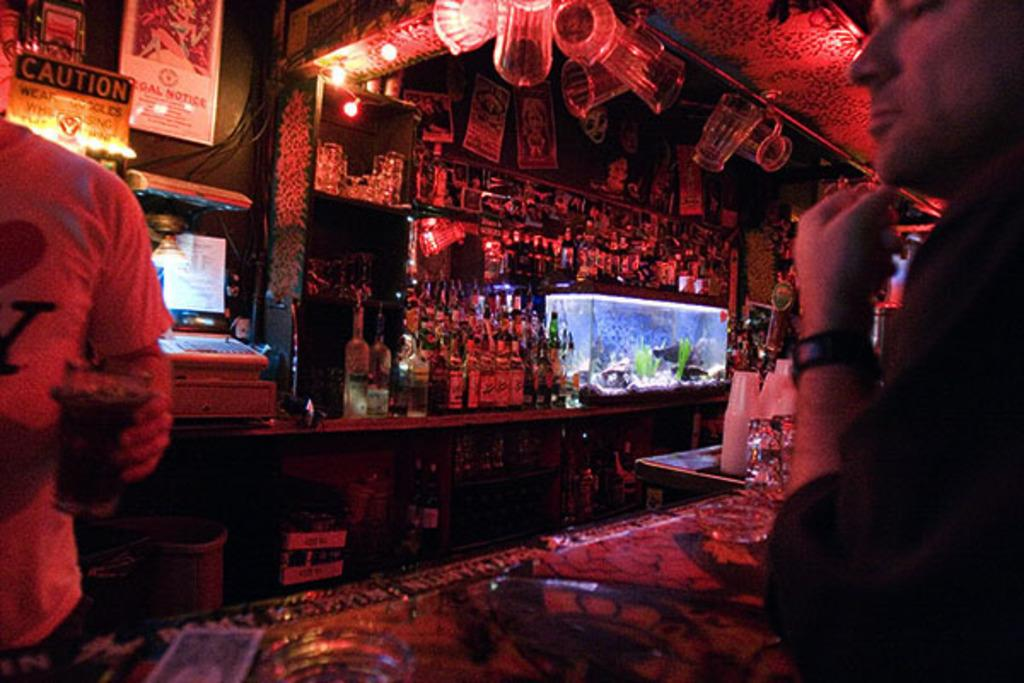How many people are present in the image? There are two people in the image. What can be seen on the shelves in the image? The shelves contain bottles. How are the bottles arranged on the shelves? The bottles are arranged on the shelves. What other objects can be seen in the image? There are boards and an aquarium in the image. What type of meal is being prepared in the image? There is no indication of a meal being prepared in the image. 